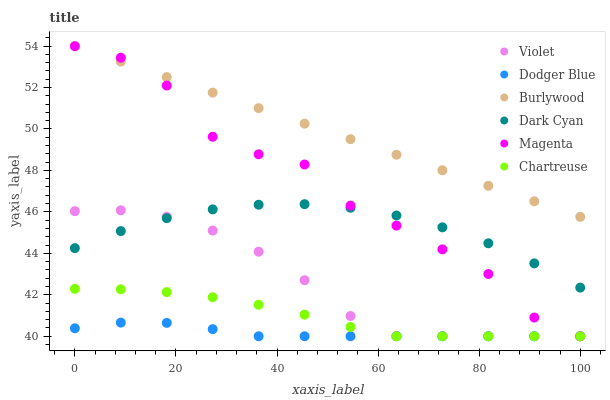Does Dodger Blue have the minimum area under the curve?
Answer yes or no. Yes. Does Burlywood have the maximum area under the curve?
Answer yes or no. Yes. Does Chartreuse have the minimum area under the curve?
Answer yes or no. No. Does Chartreuse have the maximum area under the curve?
Answer yes or no. No. Is Burlywood the smoothest?
Answer yes or no. Yes. Is Magenta the roughest?
Answer yes or no. Yes. Is Chartreuse the smoothest?
Answer yes or no. No. Is Chartreuse the roughest?
Answer yes or no. No. Does Chartreuse have the lowest value?
Answer yes or no. Yes. Does Dark Cyan have the lowest value?
Answer yes or no. No. Does Burlywood have the highest value?
Answer yes or no. Yes. Does Chartreuse have the highest value?
Answer yes or no. No. Is Violet less than Burlywood?
Answer yes or no. Yes. Is Dark Cyan greater than Dodger Blue?
Answer yes or no. Yes. Does Violet intersect Magenta?
Answer yes or no. Yes. Is Violet less than Magenta?
Answer yes or no. No. Is Violet greater than Magenta?
Answer yes or no. No. Does Violet intersect Burlywood?
Answer yes or no. No. 